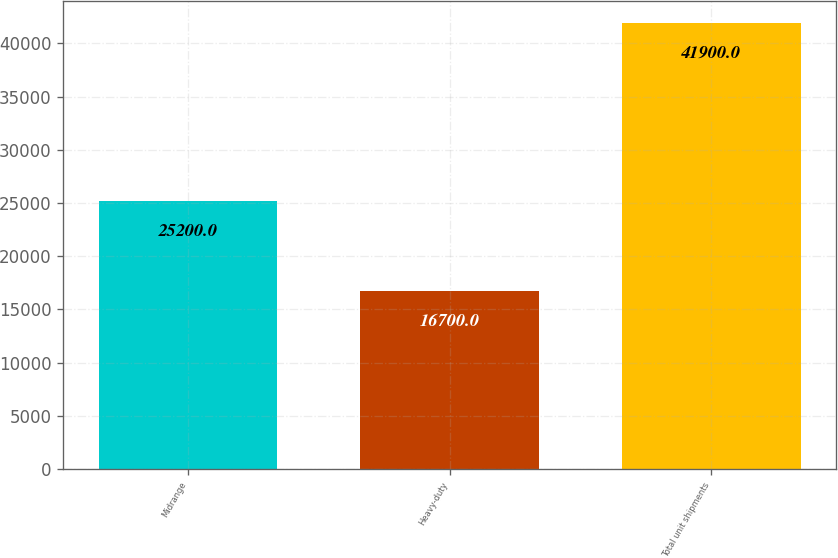<chart> <loc_0><loc_0><loc_500><loc_500><bar_chart><fcel>Midrange<fcel>Heavy-duty<fcel>Total unit shipments<nl><fcel>25200<fcel>16700<fcel>41900<nl></chart> 